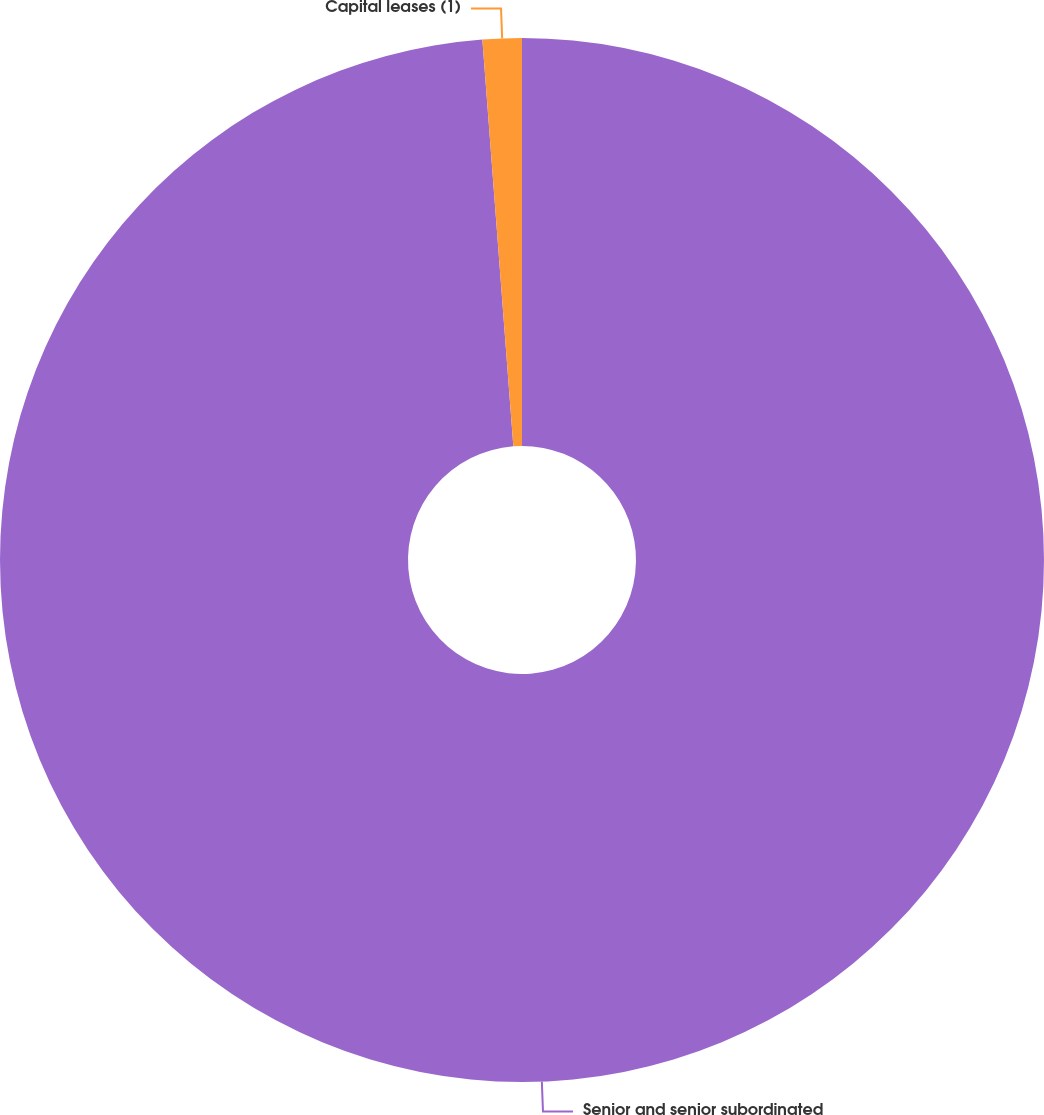Convert chart to OTSL. <chart><loc_0><loc_0><loc_500><loc_500><pie_chart><fcel>Senior and senior subordinated<fcel>Capital leases (1)<nl><fcel>98.79%<fcel>1.21%<nl></chart> 